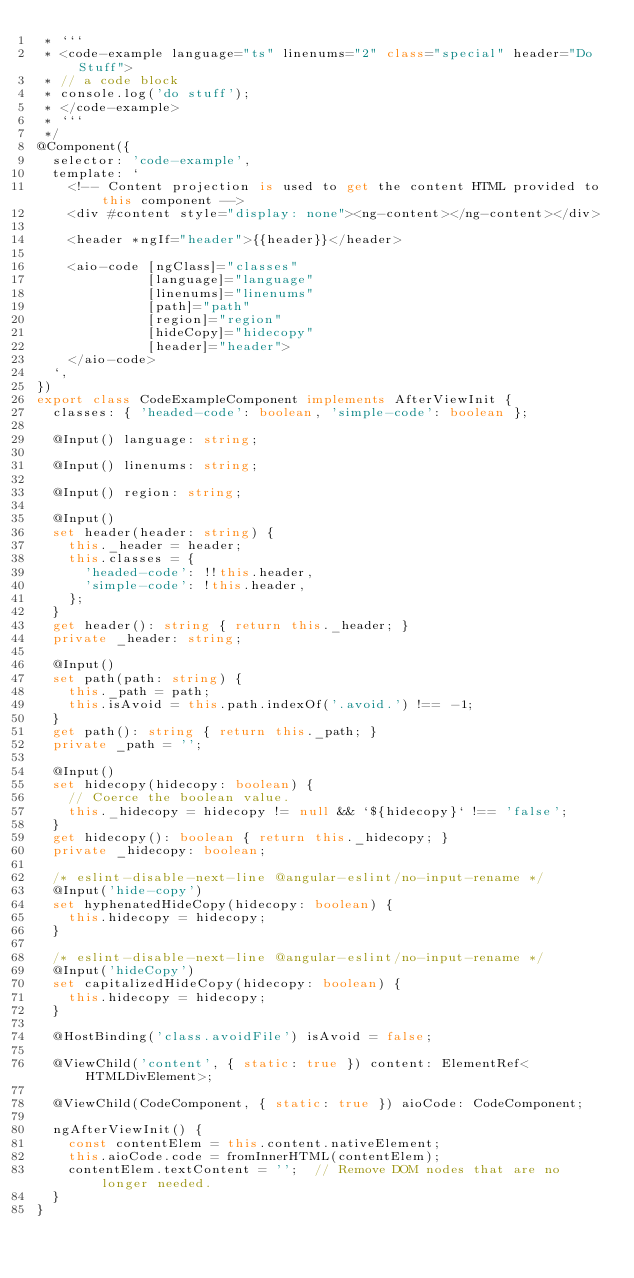<code> <loc_0><loc_0><loc_500><loc_500><_TypeScript_> * ```
 * <code-example language="ts" linenums="2" class="special" header="Do Stuff">
 * // a code block
 * console.log('do stuff');
 * </code-example>
 * ```
 */
@Component({
  selector: 'code-example',
  template: `
    <!-- Content projection is used to get the content HTML provided to this component -->
    <div #content style="display: none"><ng-content></ng-content></div>

    <header *ngIf="header">{{header}}</header>

    <aio-code [ngClass]="classes"
              [language]="language"
              [linenums]="linenums"
              [path]="path"
              [region]="region"
              [hideCopy]="hidecopy"
              [header]="header">
    </aio-code>
  `,
})
export class CodeExampleComponent implements AfterViewInit {
  classes: { 'headed-code': boolean, 'simple-code': boolean };

  @Input() language: string;

  @Input() linenums: string;

  @Input() region: string;

  @Input()
  set header(header: string) {
    this._header = header;
    this.classes = {
      'headed-code': !!this.header,
      'simple-code': !this.header,
    };
  }
  get header(): string { return this._header; }
  private _header: string;

  @Input()
  set path(path: string) {
    this._path = path;
    this.isAvoid = this.path.indexOf('.avoid.') !== -1;
  }
  get path(): string { return this._path; }
  private _path = '';

  @Input()
  set hidecopy(hidecopy: boolean) {
    // Coerce the boolean value.
    this._hidecopy = hidecopy != null && `${hidecopy}` !== 'false';
  }
  get hidecopy(): boolean { return this._hidecopy; }
  private _hidecopy: boolean;

  /* eslint-disable-next-line @angular-eslint/no-input-rename */
  @Input('hide-copy')
  set hyphenatedHideCopy(hidecopy: boolean) {
    this.hidecopy = hidecopy;
  }

  /* eslint-disable-next-line @angular-eslint/no-input-rename */
  @Input('hideCopy')
  set capitalizedHideCopy(hidecopy: boolean) {
    this.hidecopy = hidecopy;
  }

  @HostBinding('class.avoidFile') isAvoid = false;

  @ViewChild('content', { static: true }) content: ElementRef<HTMLDivElement>;

  @ViewChild(CodeComponent, { static: true }) aioCode: CodeComponent;

  ngAfterViewInit() {
    const contentElem = this.content.nativeElement;
    this.aioCode.code = fromInnerHTML(contentElem);
    contentElem.textContent = '';  // Remove DOM nodes that are no longer needed.
  }
}
</code> 